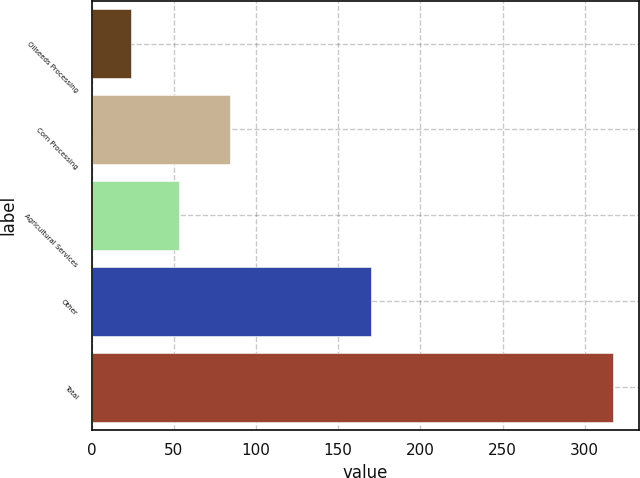Convert chart to OTSL. <chart><loc_0><loc_0><loc_500><loc_500><bar_chart><fcel>Oilseeds Processing<fcel>Corn Processing<fcel>Agricultural Services<fcel>Other<fcel>Total<nl><fcel>24<fcel>84<fcel>53.3<fcel>170<fcel>317<nl></chart> 